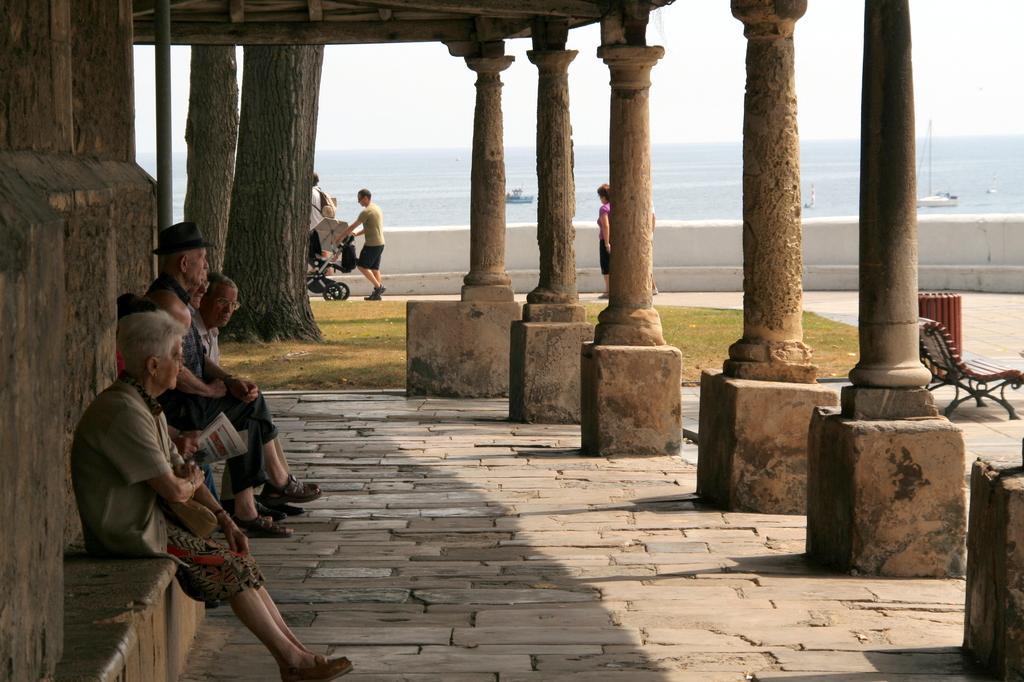Can you describe this image briefly? In this image I can see few people sitting. The person is holding trolley. We can see pillars and bench. Back Side I can see water and a ships. The sky is in white color. We can see a trees. 